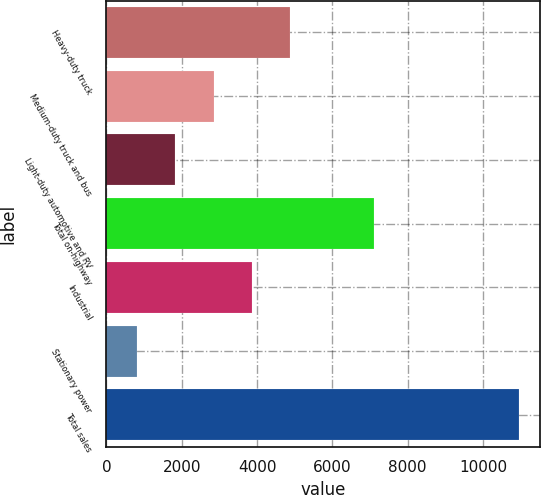Convert chart to OTSL. <chart><loc_0><loc_0><loc_500><loc_500><bar_chart><fcel>Heavy-duty truck<fcel>Medium-duty truck and bus<fcel>Light-duty automotive and RV<fcel>Total on-highway<fcel>Industrial<fcel>Stationary power<fcel>Total sales<nl><fcel>4875<fcel>2846<fcel>1831.5<fcel>7105<fcel>3860.5<fcel>817<fcel>10962<nl></chart> 